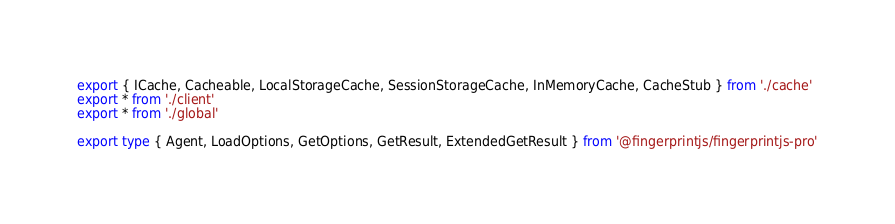Convert code to text. <code><loc_0><loc_0><loc_500><loc_500><_TypeScript_>export { ICache, Cacheable, LocalStorageCache, SessionStorageCache, InMemoryCache, CacheStub } from './cache'
export * from './client'
export * from './global'

export type { Agent, LoadOptions, GetOptions, GetResult, ExtendedGetResult } from '@fingerprintjs/fingerprintjs-pro'
</code> 